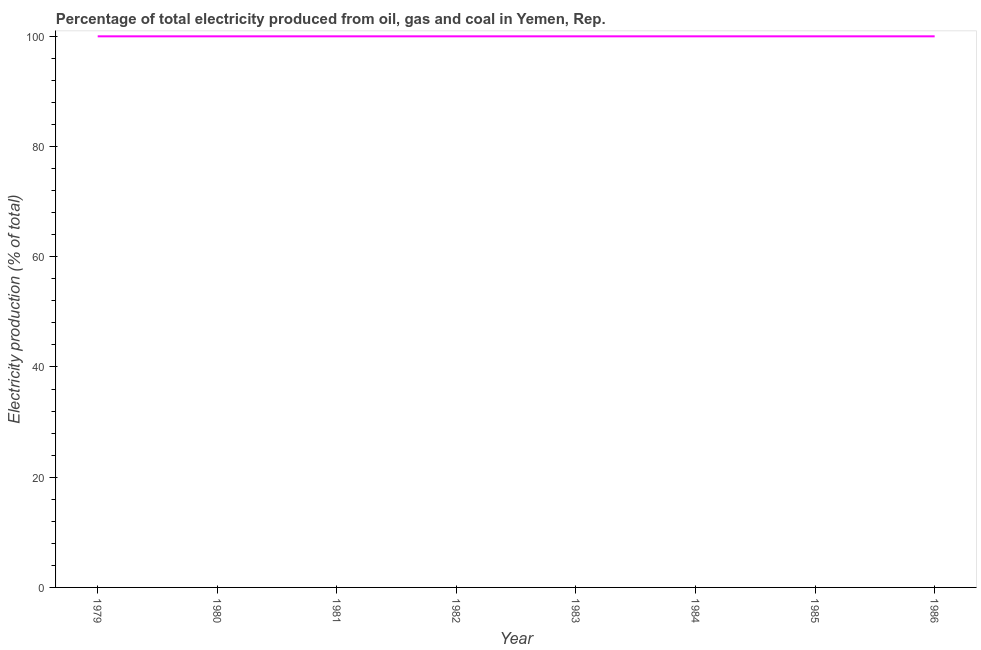What is the electricity production in 1982?
Ensure brevity in your answer.  100. Across all years, what is the maximum electricity production?
Offer a terse response. 100. Across all years, what is the minimum electricity production?
Your answer should be very brief. 100. In which year was the electricity production maximum?
Make the answer very short. 1979. In which year was the electricity production minimum?
Provide a succinct answer. 1979. What is the sum of the electricity production?
Your answer should be compact. 800. What is the difference between the electricity production in 1981 and 1983?
Provide a short and direct response. 0. In how many years, is the electricity production greater than 24 %?
Offer a terse response. 8. What is the ratio of the electricity production in 1980 to that in 1986?
Offer a terse response. 1. Is the difference between the electricity production in 1980 and 1985 greater than the difference between any two years?
Ensure brevity in your answer.  Yes. Is the sum of the electricity production in 1980 and 1981 greater than the maximum electricity production across all years?
Give a very brief answer. Yes. How many lines are there?
Make the answer very short. 1. How many years are there in the graph?
Offer a very short reply. 8. Are the values on the major ticks of Y-axis written in scientific E-notation?
Offer a very short reply. No. Does the graph contain grids?
Give a very brief answer. No. What is the title of the graph?
Your answer should be compact. Percentage of total electricity produced from oil, gas and coal in Yemen, Rep. What is the label or title of the X-axis?
Your answer should be very brief. Year. What is the label or title of the Y-axis?
Your response must be concise. Electricity production (% of total). What is the Electricity production (% of total) of 1980?
Offer a terse response. 100. What is the Electricity production (% of total) in 1982?
Offer a very short reply. 100. What is the Electricity production (% of total) in 1986?
Your answer should be very brief. 100. What is the difference between the Electricity production (% of total) in 1979 and 1980?
Your answer should be compact. 0. What is the difference between the Electricity production (% of total) in 1979 and 1981?
Offer a very short reply. 0. What is the difference between the Electricity production (% of total) in 1979 and 1983?
Provide a short and direct response. 0. What is the difference between the Electricity production (% of total) in 1979 and 1985?
Keep it short and to the point. 0. What is the difference between the Electricity production (% of total) in 1980 and 1982?
Provide a succinct answer. 0. What is the difference between the Electricity production (% of total) in 1980 and 1983?
Ensure brevity in your answer.  0. What is the difference between the Electricity production (% of total) in 1980 and 1985?
Offer a terse response. 0. What is the difference between the Electricity production (% of total) in 1980 and 1986?
Ensure brevity in your answer.  0. What is the difference between the Electricity production (% of total) in 1981 and 1985?
Offer a terse response. 0. What is the difference between the Electricity production (% of total) in 1981 and 1986?
Make the answer very short. 0. What is the difference between the Electricity production (% of total) in 1982 and 1983?
Keep it short and to the point. 0. What is the difference between the Electricity production (% of total) in 1983 and 1984?
Provide a short and direct response. 0. What is the difference between the Electricity production (% of total) in 1983 and 1986?
Keep it short and to the point. 0. What is the difference between the Electricity production (% of total) in 1984 and 1986?
Your answer should be compact. 0. What is the ratio of the Electricity production (% of total) in 1979 to that in 1981?
Give a very brief answer. 1. What is the ratio of the Electricity production (% of total) in 1979 to that in 1982?
Ensure brevity in your answer.  1. What is the ratio of the Electricity production (% of total) in 1979 to that in 1984?
Offer a terse response. 1. What is the ratio of the Electricity production (% of total) in 1979 to that in 1985?
Provide a succinct answer. 1. What is the ratio of the Electricity production (% of total) in 1980 to that in 1981?
Your response must be concise. 1. What is the ratio of the Electricity production (% of total) in 1980 to that in 1982?
Your answer should be compact. 1. What is the ratio of the Electricity production (% of total) in 1980 to that in 1983?
Your answer should be very brief. 1. What is the ratio of the Electricity production (% of total) in 1980 to that in 1984?
Offer a terse response. 1. What is the ratio of the Electricity production (% of total) in 1981 to that in 1982?
Give a very brief answer. 1. What is the ratio of the Electricity production (% of total) in 1981 to that in 1984?
Your answer should be very brief. 1. What is the ratio of the Electricity production (% of total) in 1981 to that in 1985?
Your response must be concise. 1. What is the ratio of the Electricity production (% of total) in 1981 to that in 1986?
Offer a terse response. 1. What is the ratio of the Electricity production (% of total) in 1982 to that in 1984?
Give a very brief answer. 1. What is the ratio of the Electricity production (% of total) in 1983 to that in 1984?
Offer a very short reply. 1. What is the ratio of the Electricity production (% of total) in 1983 to that in 1985?
Your response must be concise. 1. What is the ratio of the Electricity production (% of total) in 1983 to that in 1986?
Your answer should be very brief. 1. 